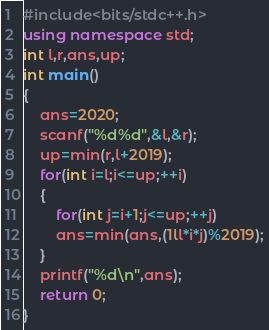<code> <loc_0><loc_0><loc_500><loc_500><_C++_>#include<bits/stdc++.h>
using namespace std;
int l,r,ans,up;
int main()
{
	ans=2020;
	scanf("%d%d",&l,&r);
	up=min(r,l+2019); 
	for(int i=l;i<=up;++i)
	{
		for(int j=i+1;j<=up;++j)
		ans=min(ans,(1ll*i*j)%2019);
	}
	printf("%d\n",ans);
    return 0;
}</code> 